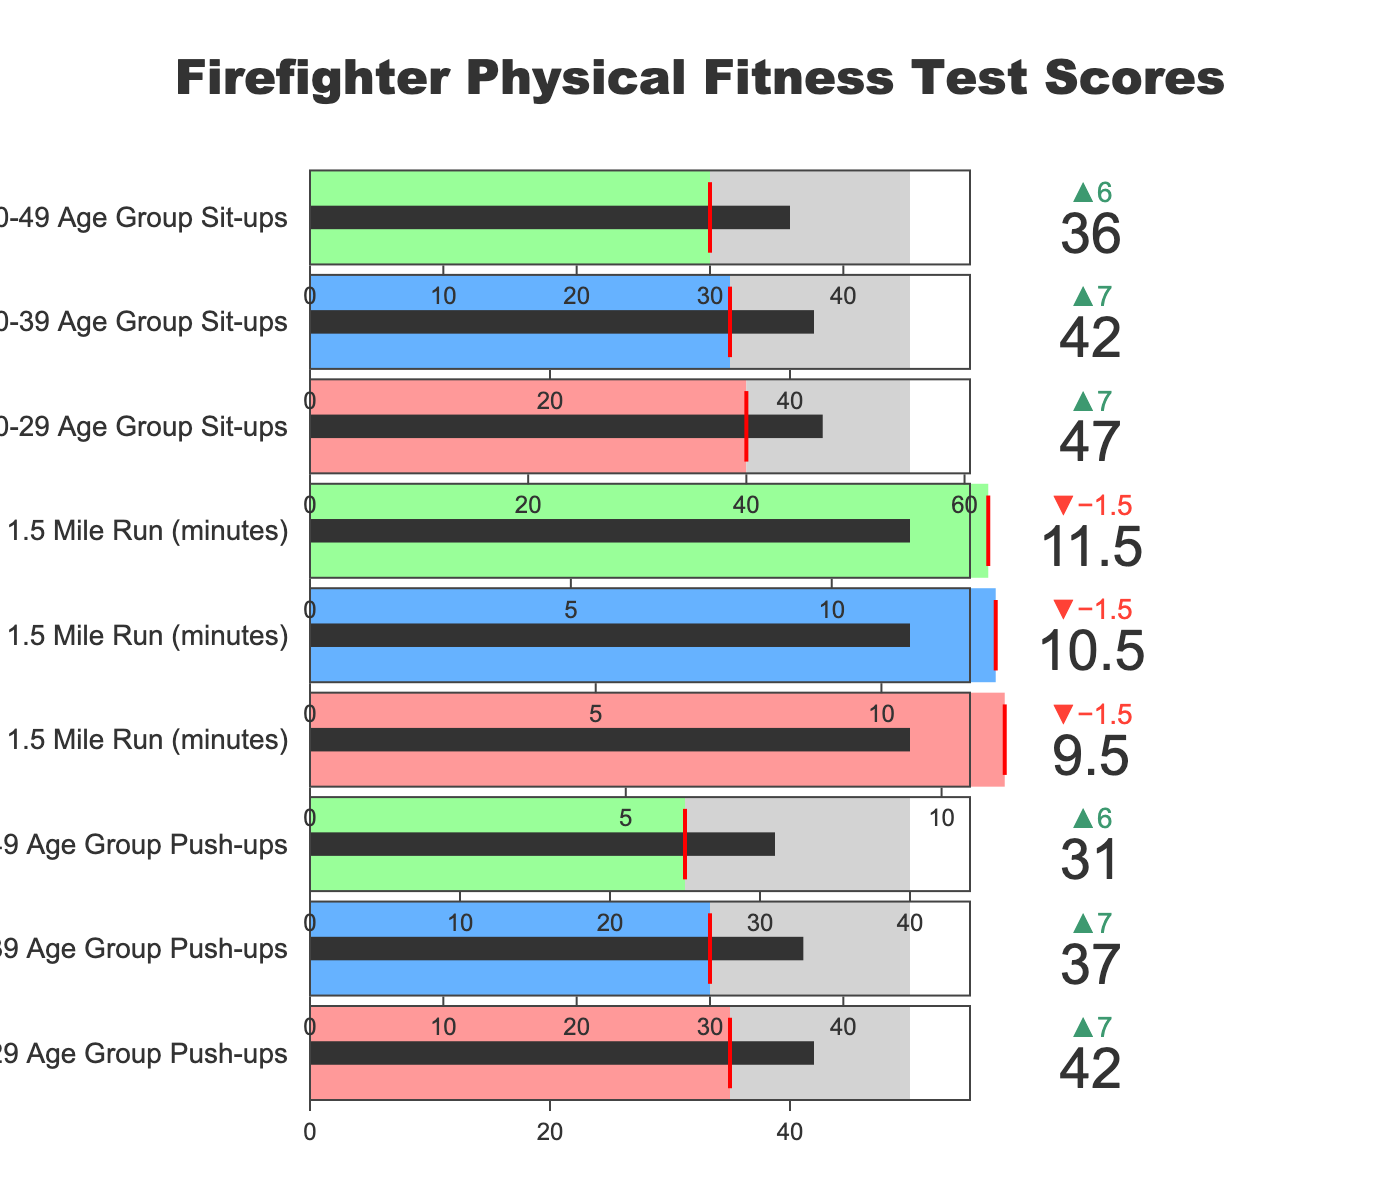What's the title of the chart? The title text is prominently displayed at the top of the chart, making it easy to read the overall subject of the visual.
Answer: Firefighter Physical Fitness Test Scores How many age groups are represented in the chart? By counting the distinct categories pertaining to different age groups in the figure, we can identify the number of age groups.
Answer: Three Which age group had the highest actual push-up score? By comparing the actual push-up scores for each age group, we find which one has the highest value. Here, 42 > 37 > 31.
Answer: 20-29 Age Group For the 1.5 Mile Run, did any age group meet their target? Inspect the bullet chart sections for each age group's 1.5 Mile Run and compare actual scores with targets. None of the actual times are less than the targets.
Answer: No What is the delta between the actual and minimum score for the 20-29 Age Group Sit-ups? Subtract the minimum score from the actual score for the specified category: 47 - 40.
Answer: 7 Which category has the smallest difference between the actual and target values? Calculate the difference between actual and target values for all categories and find the smallest difference. Here, for Sit-ups 20-29 Age Group: 55-47 = 8, the smallest gap.
Answer: 20-29 Age Group Sit-ups Are any age groups below their minimum requirements in any category? Check if actual values are less than minimum values across all categories. All actual values exceed minimum requirements.
Answer: No Comparing the average actual scores of push-ups across the age groups, which group performed the best? Average the actual push-up scores for each age group: (42+37+31)/3, then compare to find the highest average push-up score.
Answer: 20-29 Age Group In the 30-39 Age Group, how does the actual score for Sit-ups compare to the minimum and target? By visual inspection, compare the actual, minimum, and target scores for this group: 42 is greater than 35 but less than 50.
Answer: Greater than minimum, less than target What is the range of actual values for the 1.5 Mile Run across all age groups? Identify the lowest and highest actual values for the 1.5 Mile Run: 9.5 (20-29) and 11.5 (40-49), then calculate the range: 11.5 - 9.5.
Answer: 2 minutes 